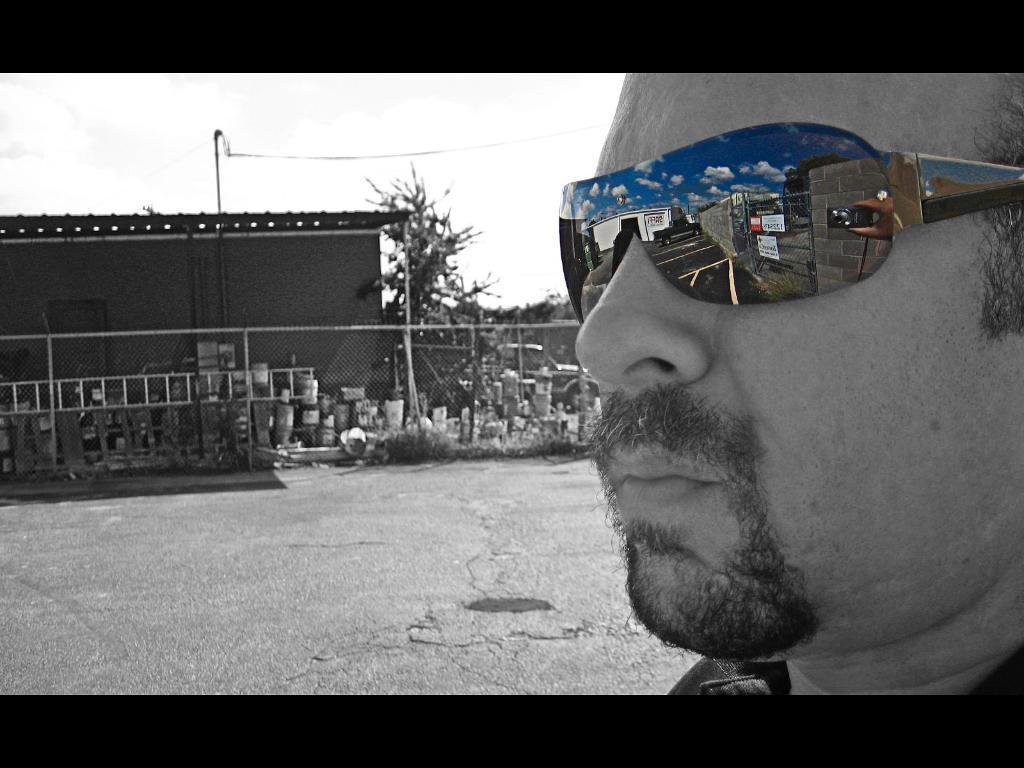Can you describe this image briefly? This is an edited image. In this image we can see a man wearing spectacles. On the backside we can see the road, some containers and a ladder beside a metal fence, a house with a roof, some trees, a pole with a wire and the sky. 